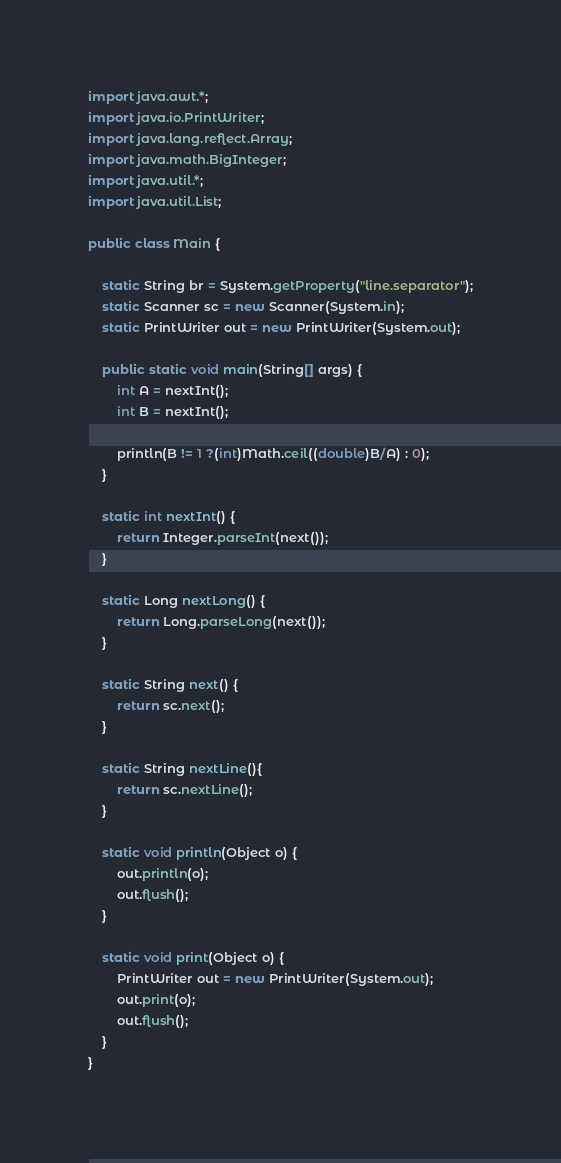Convert code to text. <code><loc_0><loc_0><loc_500><loc_500><_Java_>import java.awt.*;
import java.io.PrintWriter;
import java.lang.reflect.Array;
import java.math.BigInteger;
import java.util.*;
import java.util.List;

public class Main {

    static String br = System.getProperty("line.separator");
    static Scanner sc = new Scanner(System.in);
    static PrintWriter out = new PrintWriter(System.out);

    public static void main(String[] args) {
        int A = nextInt();
        int B = nextInt();

        println(B != 1 ?(int)Math.ceil((double)B/A) : 0);
    }

    static int nextInt() {
        return Integer.parseInt(next());
    }

    static Long nextLong() {
        return Long.parseLong(next());
    }

    static String next() {
        return sc.next();
    }

    static String nextLine(){
        return sc.nextLine();
    }

    static void println(Object o) {
        out.println(o);
        out.flush();
    }

    static void print(Object o) {
        PrintWriter out = new PrintWriter(System.out);
        out.print(o);
        out.flush();
    }
}
</code> 